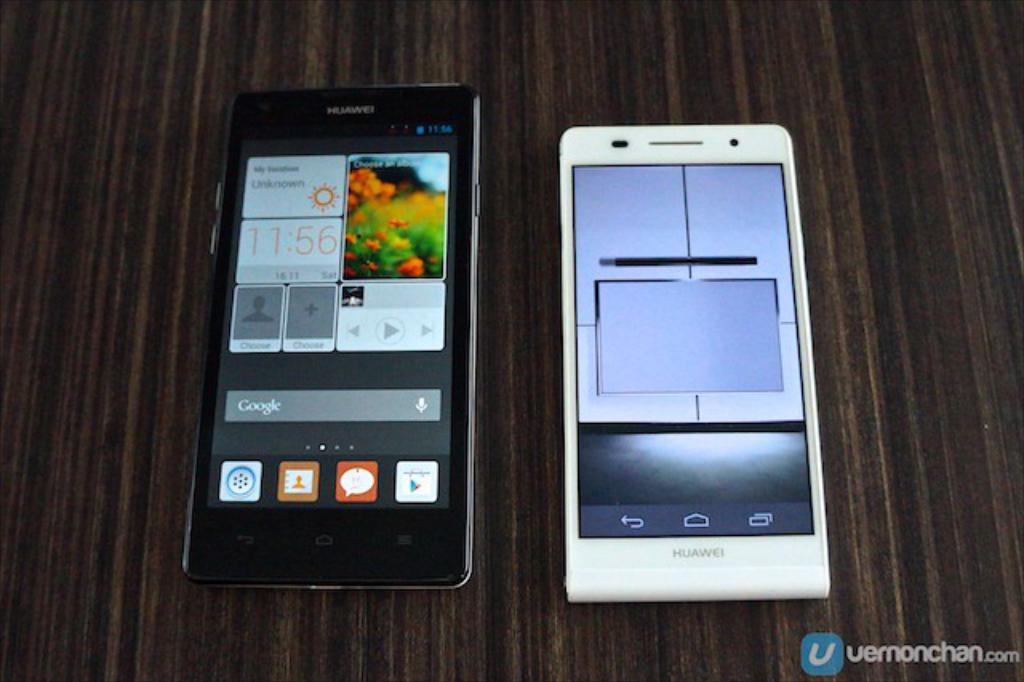What brand are these phones?
Your answer should be very brief. Huawei. What time is it?
Your answer should be very brief. 11:56. 